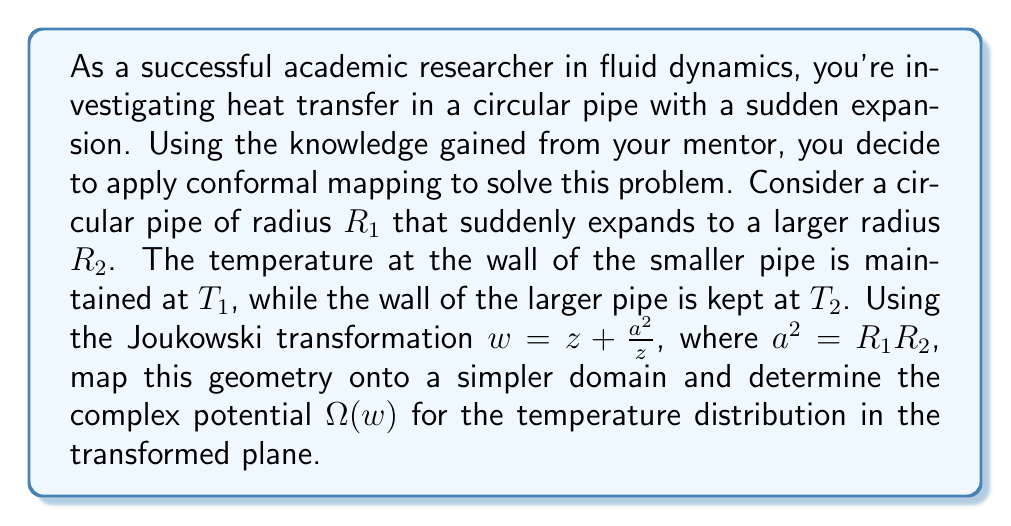Show me your answer to this math problem. Let's approach this problem step-by-step:

1) First, we need to understand the geometry of our problem. We have a circular pipe that expands from radius $R_1$ to $R_2$. This can be represented in the complex z-plane.

2) The Joukowski transformation $w = z + \frac{a^2}{z}$ with $a^2 = R_1R_2$ is used to map this geometry onto a simpler domain in the w-plane.

3) Under this transformation:
   - The circle with radius $R_1$ in the z-plane maps to a straight line segment on the real axis in the w-plane.
   - The circle with radius $R_2$ in the z-plane also maps to a straight line segment on the real axis in the w-plane.
   - The region between these circles in the z-plane maps to the upper half-plane in the w-plane.

4) In the w-plane, our problem has been simplified to finding the temperature distribution in the upper half-plane with boundary conditions specified on the real axis.

5) The complex potential in the w-plane can be written as:

   $$\Omega(w) = A \ln(w - w_1) + B \ln(w - w_2) + C$$

   where $w_1$ and $w_2$ are the points on the real axis corresponding to the ends of the line segments, and $A$, $B$, and $C$ are constants to be determined from the boundary conditions.

6) The temperature $T$ is related to the imaginary part of $\Omega(w)$:

   $$T = \Im[\Omega(w)]$$

7) To determine the constants $A$, $B$, and $C$, we need to apply the boundary conditions:
   - $T = T_1$ on the line segment corresponding to the smaller pipe
   - $T = T_2$ on the line segment corresponding to the larger pipe

8) These conditions lead to a system of equations that can be solved for $A$, $B$, and $C$.
Answer: The complex potential for the temperature distribution in the transformed w-plane is:

$$\Omega(w) = A \ln(w - w_1) + B \ln(w - w_2) + C$$

where $A$, $B$, and $C$ are constants determined by the boundary conditions, and $w_1$ and $w_2$ are the endpoints of the transformed pipe sections on the real axis in the w-plane. 